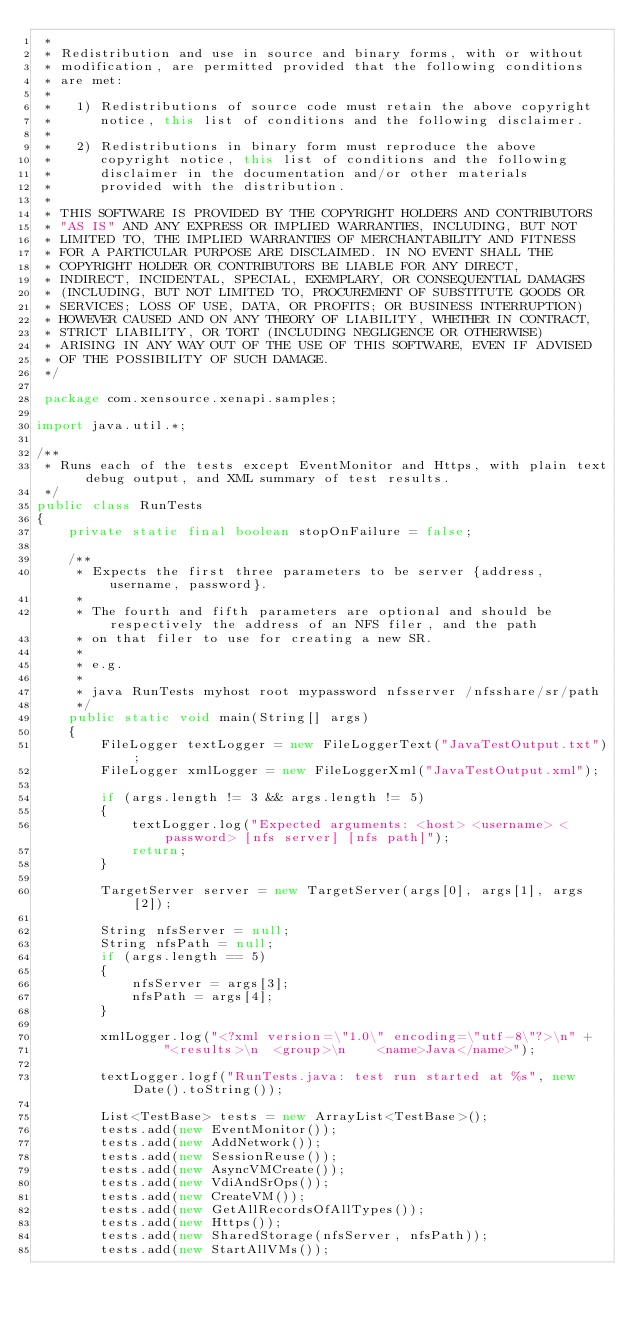<code> <loc_0><loc_0><loc_500><loc_500><_Java_> * 
 * Redistribution and use in source and binary forms, with or without
 * modification, are permitted provided that the following conditions
 * are met:
 * 
 *   1) Redistributions of source code must retain the above copyright
 *      notice, this list of conditions and the following disclaimer.
 * 
 *   2) Redistributions in binary form must reproduce the above
 *      copyright notice, this list of conditions and the following
 *      disclaimer in the documentation and/or other materials
 *      provided with the distribution.
 * 
 * THIS SOFTWARE IS PROVIDED BY THE COPYRIGHT HOLDERS AND CONTRIBUTORS
 * "AS IS" AND ANY EXPRESS OR IMPLIED WARRANTIES, INCLUDING, BUT NOT
 * LIMITED TO, THE IMPLIED WARRANTIES OF MERCHANTABILITY AND FITNESS
 * FOR A PARTICULAR PURPOSE ARE DISCLAIMED. IN NO EVENT SHALL THE
 * COPYRIGHT HOLDER OR CONTRIBUTORS BE LIABLE FOR ANY DIRECT,
 * INDIRECT, INCIDENTAL, SPECIAL, EXEMPLARY, OR CONSEQUENTIAL DAMAGES
 * (INCLUDING, BUT NOT LIMITED TO, PROCUREMENT OF SUBSTITUTE GOODS OR
 * SERVICES; LOSS OF USE, DATA, OR PROFITS; OR BUSINESS INTERRUPTION)
 * HOWEVER CAUSED AND ON ANY THEORY OF LIABILITY, WHETHER IN CONTRACT,
 * STRICT LIABILITY, OR TORT (INCLUDING NEGLIGENCE OR OTHERWISE)
 * ARISING IN ANY WAY OUT OF THE USE OF THIS SOFTWARE, EVEN IF ADVISED
 * OF THE POSSIBILITY OF SUCH DAMAGE.
 */

 package com.xensource.xenapi.samples;

import java.util.*;

/**
 * Runs each of the tests except EventMonitor and Https, with plain text debug output, and XML summary of test results.
 */
public class RunTests
{
    private static final boolean stopOnFailure = false;

    /**
     * Expects the first three parameters to be server {address, username, password}.
     * 
     * The fourth and fifth parameters are optional and should be respectively the address of an NFS filer, and the path
     * on that filer to use for creating a new SR.
     * 
     * e.g.
     * 
     * java RunTests myhost root mypassword nfsserver /nfsshare/sr/path
     */
    public static void main(String[] args)
    {
        FileLogger textLogger = new FileLoggerText("JavaTestOutput.txt");
        FileLogger xmlLogger = new FileLoggerXml("JavaTestOutput.xml");

        if (args.length != 3 && args.length != 5)
        {
            textLogger.log("Expected arguments: <host> <username> <password> [nfs server] [nfs path]");
            return;
        }

        TargetServer server = new TargetServer(args[0], args[1], args[2]);

        String nfsServer = null;
        String nfsPath = null;
        if (args.length == 5)
        {
            nfsServer = args[3];
            nfsPath = args[4];
        }

        xmlLogger.log("<?xml version=\"1.0\" encoding=\"utf-8\"?>\n" +
                "<results>\n  <group>\n    <name>Java</name>");

        textLogger.logf("RunTests.java: test run started at %s", new Date().toString());

        List<TestBase> tests = new ArrayList<TestBase>();
        tests.add(new EventMonitor());
        tests.add(new AddNetwork());
        tests.add(new SessionReuse());
        tests.add(new AsyncVMCreate());
        tests.add(new VdiAndSrOps());
        tests.add(new CreateVM());
        tests.add(new GetAllRecordsOfAllTypes());
        tests.add(new Https());
        tests.add(new SharedStorage(nfsServer, nfsPath));
        tests.add(new StartAllVMs());
</code> 